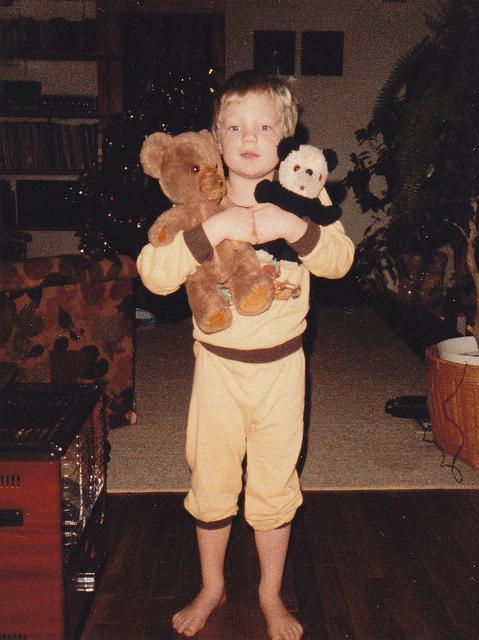Is this taken in the summertime?
Short answer required. No. What holiday was this taken during?
Be succinct. Christmas. Which type of animal is the boy holding?
Short answer required. Bear. 